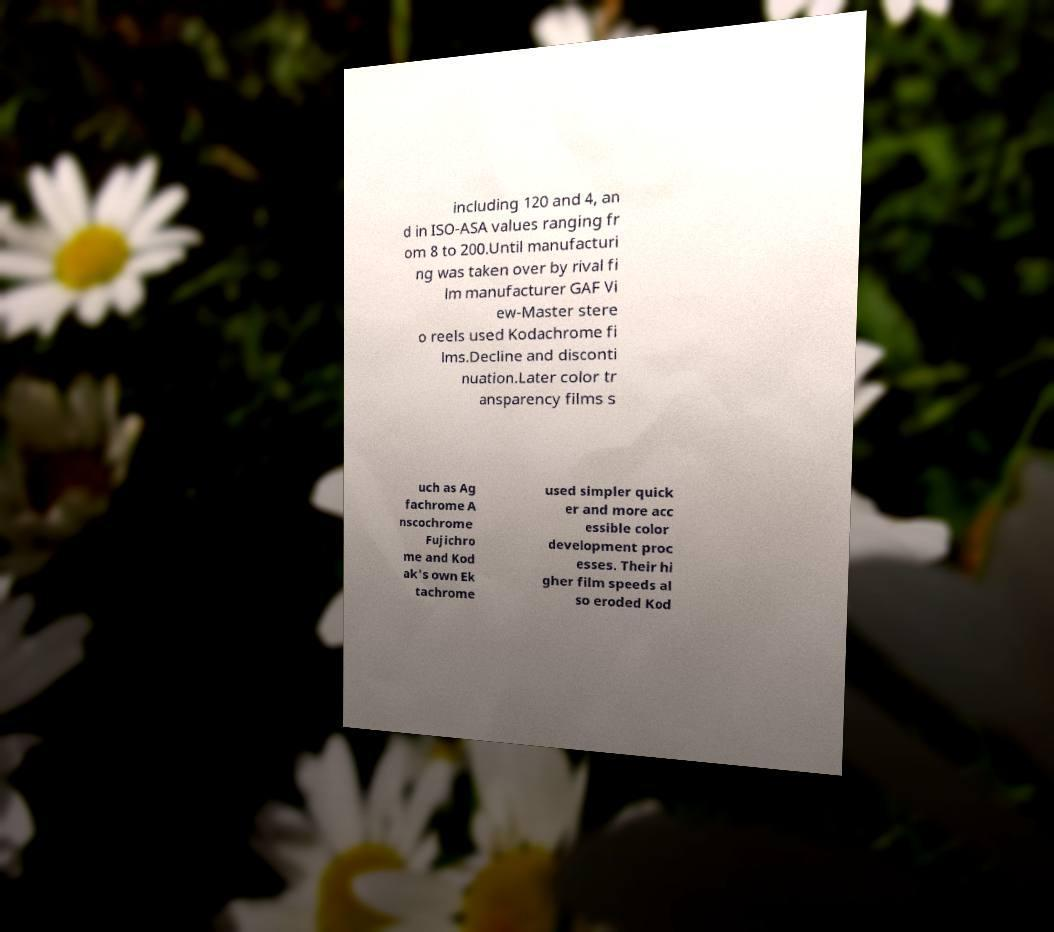There's text embedded in this image that I need extracted. Can you transcribe it verbatim? including 120 and 4, an d in ISO-ASA values ranging fr om 8 to 200.Until manufacturi ng was taken over by rival fi lm manufacturer GAF Vi ew-Master stere o reels used Kodachrome fi lms.Decline and disconti nuation.Later color tr ansparency films s uch as Ag fachrome A nscochrome Fujichro me and Kod ak's own Ek tachrome used simpler quick er and more acc essible color development proc esses. Their hi gher film speeds al so eroded Kod 